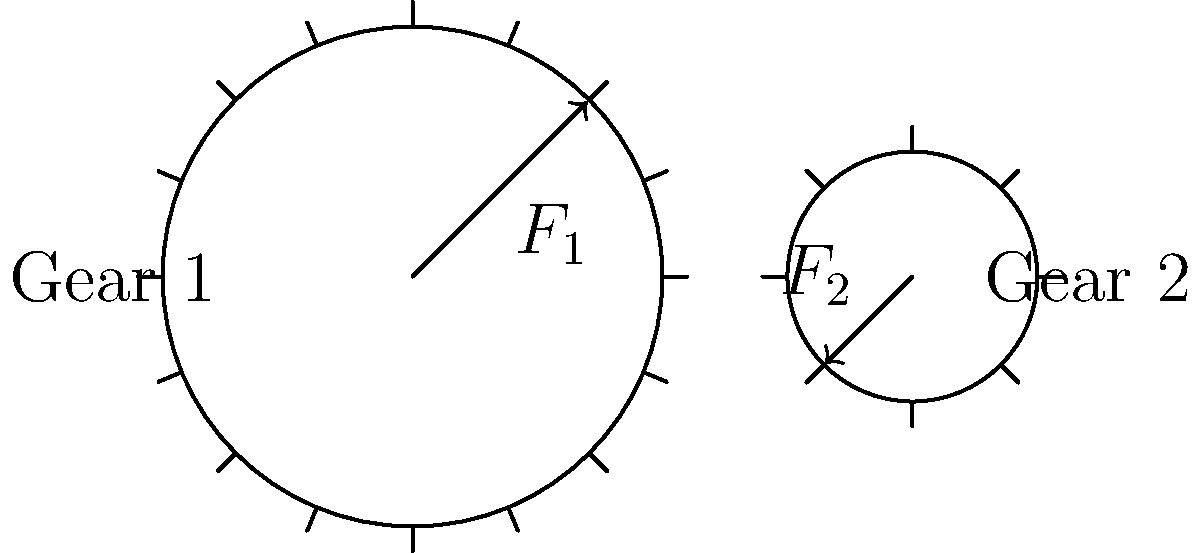In the gear system shown, Gear 1 has a radius of 10 cm and Gear 2 has a radius of 5 cm. If a force $F_1 = 100$ N is applied tangentially to Gear 1, what is the magnitude of the tangential force $F_2$ acting on Gear 2? Assume the system is in equilibrium and neglect friction. To solve this problem, we'll use the principle of conservation of energy and the concept of torque balance:

1) In an ideal gear system, the power transmitted from one gear to another is conserved.

2) Power is the product of torque and angular velocity. For each gear:
   $P = T\omega$, where $T$ is torque and $\omega$ is angular velocity.

3) Torque is the product of force and radius: $T = Fr$

4) The ratio of angular velocities is inversely proportional to the ratio of radii:
   $\frac{\omega_1}{\omega_2} = \frac{r_2}{r_1}$

5) Equating the power for both gears:
   $T_1\omega_1 = T_2\omega_2$

6) Substituting the expressions for torque and the ratio of angular velocities:
   $F_1r_1 \cdot \frac{\omega_2r_2}{r_1} = F_2r_2 \cdot \omega_2$

7) The $\omega_2$ cancels out:
   $F_1r_1 \cdot \frac{r_2}{r_1} = F_2r_2$

8) Simplifying:
   $F_1r_2 = F_2r_1$

9) Solving for $F_2$:
   $F_2 = F_1 \cdot \frac{r_2}{r_1}$

10) Substituting the given values:
    $F_2 = 100 \text{ N} \cdot \frac{5 \text{ cm}}{10 \text{ cm}} = 50 \text{ N}$

Therefore, the magnitude of the tangential force $F_2$ acting on Gear 2 is 50 N.
Answer: $F_2 = 50 \text{ N}$ 